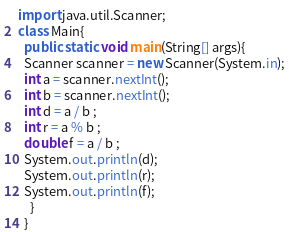Convert code to text. <code><loc_0><loc_0><loc_500><loc_500><_Java_>import java.util.Scanner;
class Main{
  public static void main(String[] args){
  Scanner scanner = new Scanner(System.in);
  int a = scanner.nextInt();
  int b = scanner.nextInt();
  int d = a / b ;
  int r = a % b ;
  double f = a / b ;
  System.out.println(d);
  System.out.println(r);
  System.out.println(f);
    }
  }</code> 